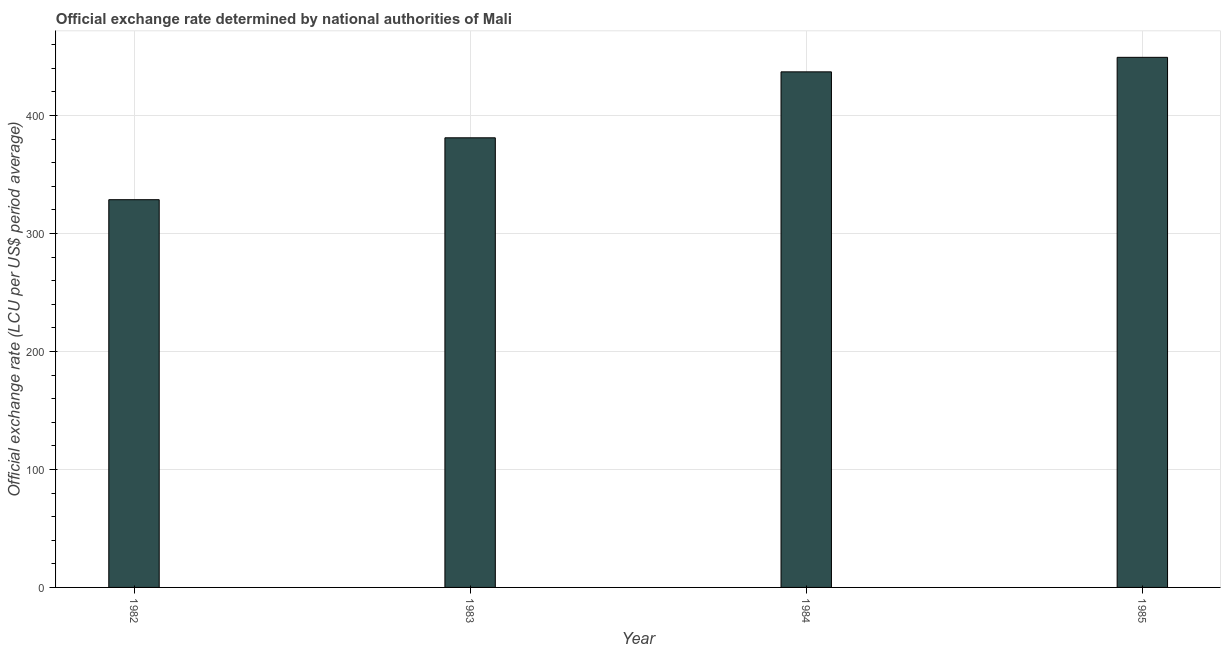What is the title of the graph?
Provide a short and direct response. Official exchange rate determined by national authorities of Mali. What is the label or title of the Y-axis?
Provide a succinct answer. Official exchange rate (LCU per US$ period average). What is the official exchange rate in 1984?
Ensure brevity in your answer.  436.96. Across all years, what is the maximum official exchange rate?
Offer a very short reply. 449.26. Across all years, what is the minimum official exchange rate?
Make the answer very short. 328.61. In which year was the official exchange rate minimum?
Give a very brief answer. 1982. What is the sum of the official exchange rate?
Your answer should be compact. 1595.89. What is the difference between the official exchange rate in 1982 and 1984?
Offer a terse response. -108.35. What is the average official exchange rate per year?
Provide a succinct answer. 398.97. What is the median official exchange rate?
Your answer should be compact. 409.01. In how many years, is the official exchange rate greater than 160 ?
Ensure brevity in your answer.  4. Do a majority of the years between 1984 and 1985 (inclusive) have official exchange rate greater than 380 ?
Provide a succinct answer. Yes. What is the ratio of the official exchange rate in 1982 to that in 1985?
Provide a short and direct response. 0.73. Is the official exchange rate in 1982 less than that in 1983?
Offer a terse response. Yes. What is the difference between the highest and the second highest official exchange rate?
Provide a short and direct response. 12.31. Is the sum of the official exchange rate in 1983 and 1984 greater than the maximum official exchange rate across all years?
Your response must be concise. Yes. What is the difference between the highest and the lowest official exchange rate?
Your answer should be compact. 120.66. Are all the bars in the graph horizontal?
Your answer should be very brief. No. How many years are there in the graph?
Your response must be concise. 4. What is the difference between two consecutive major ticks on the Y-axis?
Your answer should be very brief. 100. What is the Official exchange rate (LCU per US$ period average) in 1982?
Provide a short and direct response. 328.61. What is the Official exchange rate (LCU per US$ period average) of 1983?
Your answer should be compact. 381.07. What is the Official exchange rate (LCU per US$ period average) of 1984?
Make the answer very short. 436.96. What is the Official exchange rate (LCU per US$ period average) of 1985?
Provide a short and direct response. 449.26. What is the difference between the Official exchange rate (LCU per US$ period average) in 1982 and 1983?
Your response must be concise. -52.46. What is the difference between the Official exchange rate (LCU per US$ period average) in 1982 and 1984?
Give a very brief answer. -108.35. What is the difference between the Official exchange rate (LCU per US$ period average) in 1982 and 1985?
Ensure brevity in your answer.  -120.66. What is the difference between the Official exchange rate (LCU per US$ period average) in 1983 and 1984?
Offer a terse response. -55.89. What is the difference between the Official exchange rate (LCU per US$ period average) in 1983 and 1985?
Provide a succinct answer. -68.2. What is the difference between the Official exchange rate (LCU per US$ period average) in 1984 and 1985?
Ensure brevity in your answer.  -12.31. What is the ratio of the Official exchange rate (LCU per US$ period average) in 1982 to that in 1983?
Give a very brief answer. 0.86. What is the ratio of the Official exchange rate (LCU per US$ period average) in 1982 to that in 1984?
Offer a very short reply. 0.75. What is the ratio of the Official exchange rate (LCU per US$ period average) in 1982 to that in 1985?
Make the answer very short. 0.73. What is the ratio of the Official exchange rate (LCU per US$ period average) in 1983 to that in 1984?
Provide a short and direct response. 0.87. What is the ratio of the Official exchange rate (LCU per US$ period average) in 1983 to that in 1985?
Provide a short and direct response. 0.85. What is the ratio of the Official exchange rate (LCU per US$ period average) in 1984 to that in 1985?
Give a very brief answer. 0.97. 